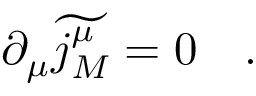Convert formula to latex. <formula><loc_0><loc_0><loc_500><loc_500>\partial _ { \mu } \widetilde { j _ { M } ^ { \mu } } = 0 \quad .</formula> 